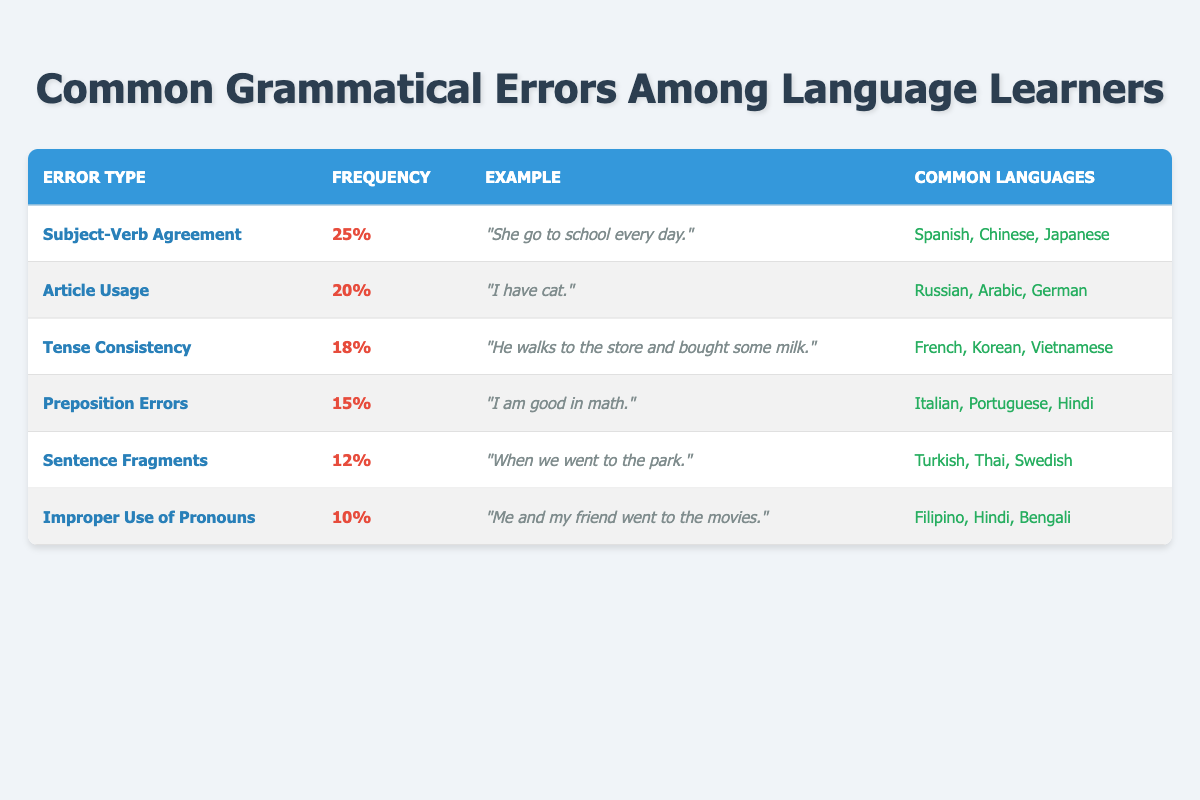What is the most common grammatical error among language learners? According to the table, the most common grammatical error is "Subject-Verb Agreement," with a frequency percentage of 25%.
Answer: Subject-Verb Agreement Which grammatical error has the lowest frequency percentage? The grammatical error with the lowest frequency percentage is "Improper Use of Pronouns," which has a frequency of 10%.
Answer: Improper Use of Pronouns How many errors have a frequency percentage of 15% or higher? The errors with a frequency percentage of 15% or higher are "Subject-Verb Agreement" (25%), "Article Usage" (20%), "Tense Consistency" (18%), and "Preposition Errors" (15%). This gives a total of 4 errors.
Answer: 4 True or False: "Sentence Fragments" has a higher frequency percentage than "Tense Consistency." "Sentence Fragments" has a frequency percentage of 12%, while "Tense Consistency" has 18%. Therefore, the statement is false.
Answer: False Which type of grammatical error is associated with the highest percentage of language learners whose common languages include Spanish, Chinese, and Japanese? The error type associated with the highest percentage of these learners is "Subject-Verb Agreement," with a frequency of 25%.
Answer: Subject-Verb Agreement What is the average frequency percentage of all the grammatical errors listed in the table? First, we add the frequency percentages: 25 + 20 + 18 + 15 + 12 + 10 = 110. Then, divide by the number of errors: 110 / 6 = 18.33.
Answer: 18.33 Are "Preposition Errors" more common than "Article Usage"? "Preposition Errors" has a frequency percentage of 15%, while "Article Usage" has 20%. Therefore, "Preposition Errors" are not more common than "Article Usage."
Answer: No Which common languages are associated with "Improper Use of Pronouns"? "Improper Use of Pronouns" is commonly associated with Filipino, Hindi, and Bengali.
Answer: Filipino, Hindi, Bengali 